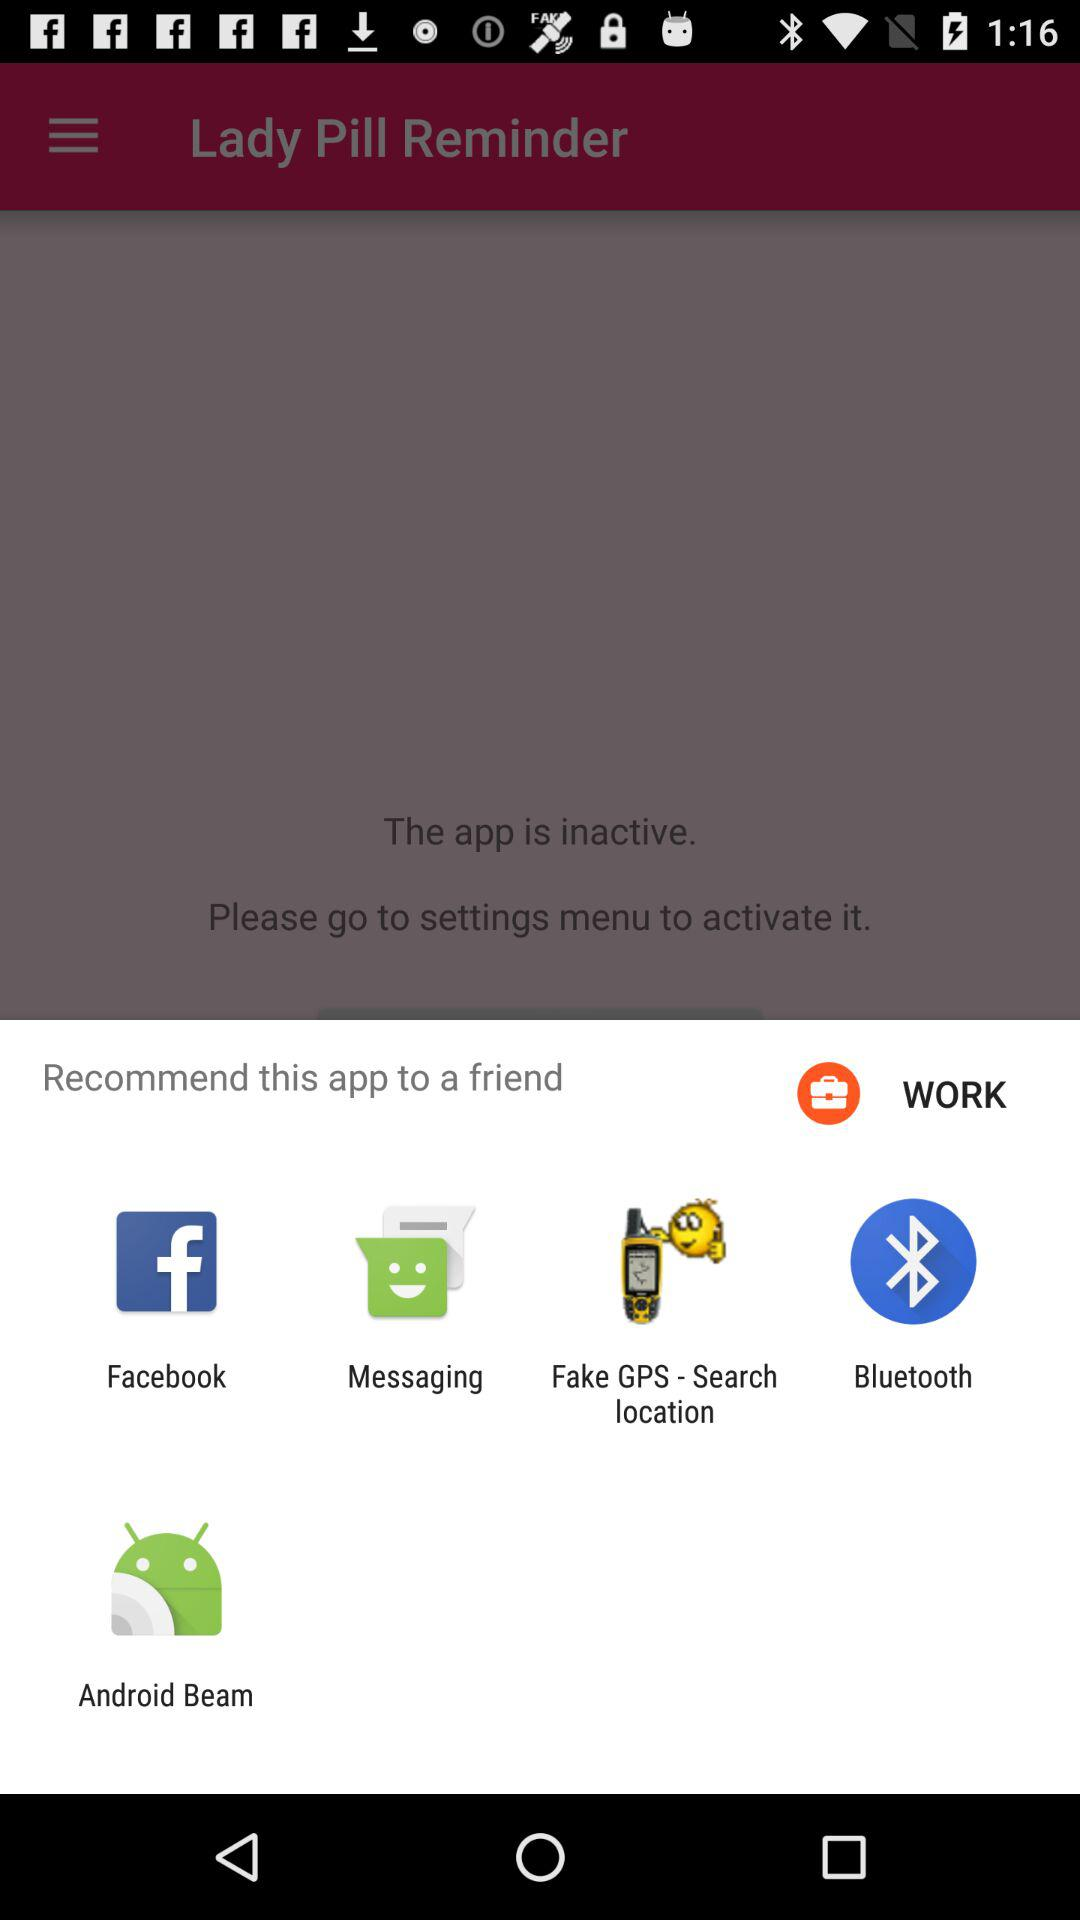What is the status of the application? The status of the application is "inactive". 